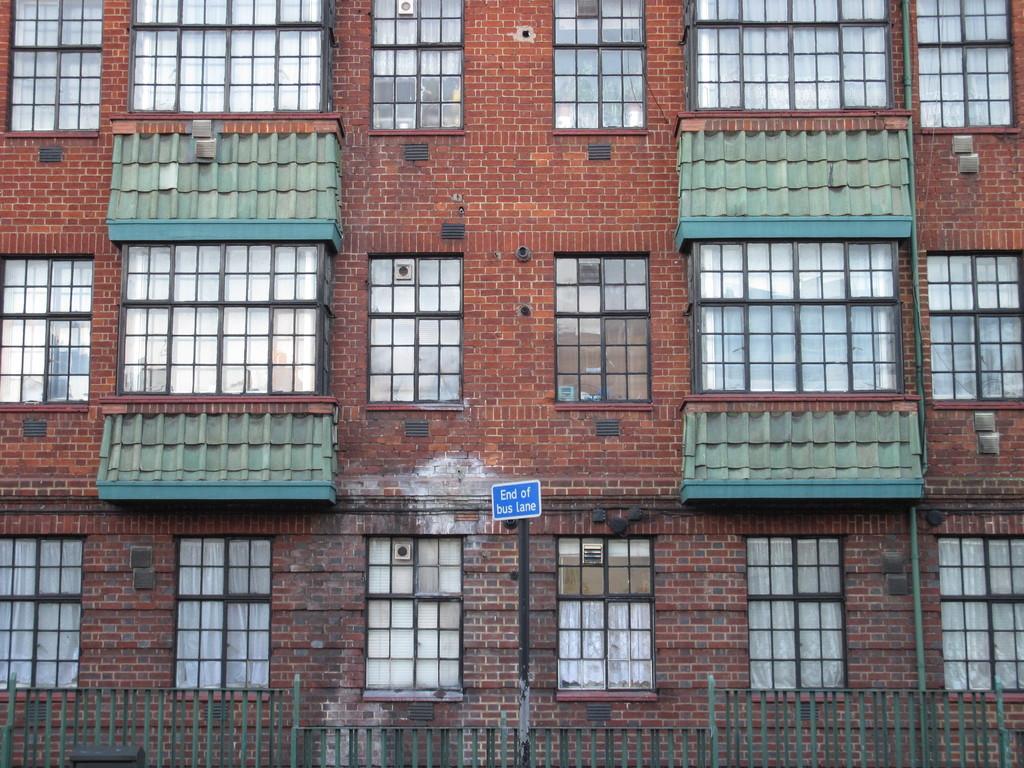Describe this image in one or two sentences. In this image we can see windows, buildings, sign board and fencing. 